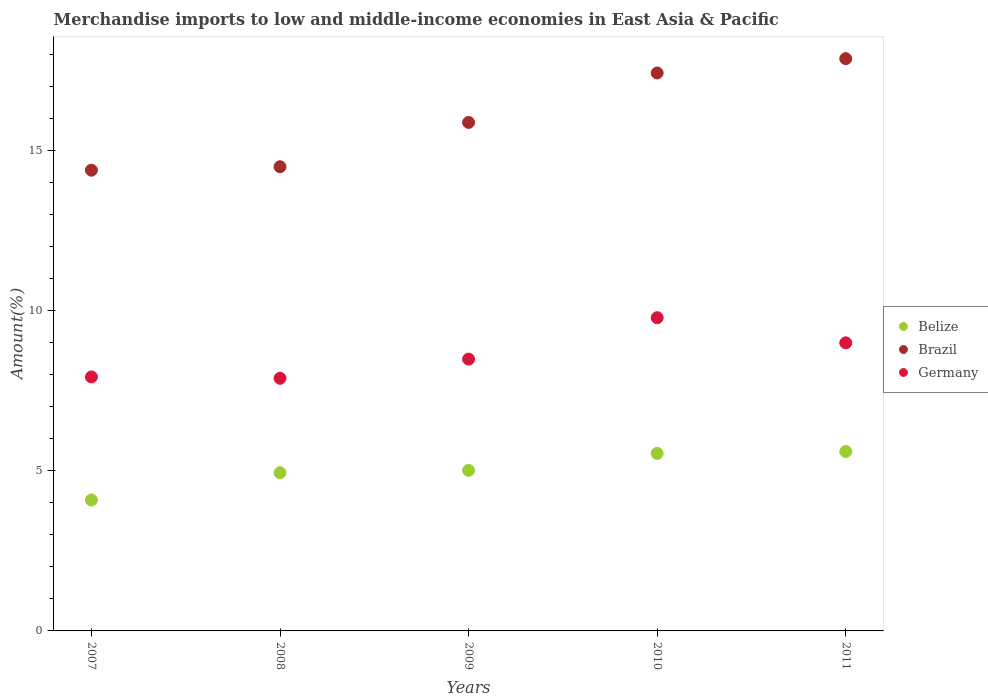What is the percentage of amount earned from merchandise imports in Belize in 2010?
Give a very brief answer. 5.54. Across all years, what is the maximum percentage of amount earned from merchandise imports in Germany?
Your response must be concise. 9.78. Across all years, what is the minimum percentage of amount earned from merchandise imports in Belize?
Offer a very short reply. 4.09. What is the total percentage of amount earned from merchandise imports in Germany in the graph?
Ensure brevity in your answer.  43.07. What is the difference between the percentage of amount earned from merchandise imports in Germany in 2007 and that in 2008?
Your answer should be very brief. 0.04. What is the difference between the percentage of amount earned from merchandise imports in Belize in 2008 and the percentage of amount earned from merchandise imports in Brazil in 2007?
Give a very brief answer. -9.44. What is the average percentage of amount earned from merchandise imports in Belize per year?
Your answer should be very brief. 5.04. In the year 2007, what is the difference between the percentage of amount earned from merchandise imports in Brazil and percentage of amount earned from merchandise imports in Germany?
Provide a succinct answer. 6.45. What is the ratio of the percentage of amount earned from merchandise imports in Belize in 2007 to that in 2009?
Offer a very short reply. 0.82. What is the difference between the highest and the second highest percentage of amount earned from merchandise imports in Brazil?
Make the answer very short. 0.45. What is the difference between the highest and the lowest percentage of amount earned from merchandise imports in Belize?
Give a very brief answer. 1.51. Is the sum of the percentage of amount earned from merchandise imports in Germany in 2007 and 2010 greater than the maximum percentage of amount earned from merchandise imports in Belize across all years?
Give a very brief answer. Yes. Is it the case that in every year, the sum of the percentage of amount earned from merchandise imports in Brazil and percentage of amount earned from merchandise imports in Belize  is greater than the percentage of amount earned from merchandise imports in Germany?
Provide a succinct answer. Yes. Is the percentage of amount earned from merchandise imports in Belize strictly greater than the percentage of amount earned from merchandise imports in Germany over the years?
Provide a short and direct response. No. How many years are there in the graph?
Keep it short and to the point. 5. Does the graph contain any zero values?
Provide a short and direct response. No. Does the graph contain grids?
Give a very brief answer. No. Where does the legend appear in the graph?
Ensure brevity in your answer.  Center right. How many legend labels are there?
Provide a short and direct response. 3. What is the title of the graph?
Provide a succinct answer. Merchandise imports to low and middle-income economies in East Asia & Pacific. What is the label or title of the Y-axis?
Give a very brief answer. Amount(%). What is the Amount(%) of Belize in 2007?
Your answer should be compact. 4.09. What is the Amount(%) in Brazil in 2007?
Offer a very short reply. 14.38. What is the Amount(%) in Germany in 2007?
Offer a very short reply. 7.93. What is the Amount(%) of Belize in 2008?
Give a very brief answer. 4.94. What is the Amount(%) in Brazil in 2008?
Keep it short and to the point. 14.49. What is the Amount(%) in Germany in 2008?
Give a very brief answer. 7.89. What is the Amount(%) in Belize in 2009?
Provide a succinct answer. 5.01. What is the Amount(%) of Brazil in 2009?
Offer a terse response. 15.87. What is the Amount(%) in Germany in 2009?
Your answer should be compact. 8.49. What is the Amount(%) of Belize in 2010?
Your response must be concise. 5.54. What is the Amount(%) of Brazil in 2010?
Your answer should be very brief. 17.42. What is the Amount(%) in Germany in 2010?
Keep it short and to the point. 9.78. What is the Amount(%) of Belize in 2011?
Give a very brief answer. 5.6. What is the Amount(%) of Brazil in 2011?
Your response must be concise. 17.87. What is the Amount(%) in Germany in 2011?
Keep it short and to the point. 8.99. Across all years, what is the maximum Amount(%) of Belize?
Your answer should be compact. 5.6. Across all years, what is the maximum Amount(%) in Brazil?
Keep it short and to the point. 17.87. Across all years, what is the maximum Amount(%) in Germany?
Offer a terse response. 9.78. Across all years, what is the minimum Amount(%) in Belize?
Your answer should be very brief. 4.09. Across all years, what is the minimum Amount(%) of Brazil?
Provide a short and direct response. 14.38. Across all years, what is the minimum Amount(%) in Germany?
Provide a succinct answer. 7.89. What is the total Amount(%) of Belize in the graph?
Offer a very short reply. 25.18. What is the total Amount(%) in Brazil in the graph?
Your answer should be compact. 80.03. What is the total Amount(%) in Germany in the graph?
Make the answer very short. 43.07. What is the difference between the Amount(%) of Belize in 2007 and that in 2008?
Provide a succinct answer. -0.85. What is the difference between the Amount(%) in Brazil in 2007 and that in 2008?
Provide a short and direct response. -0.11. What is the difference between the Amount(%) of Germany in 2007 and that in 2008?
Keep it short and to the point. 0.04. What is the difference between the Amount(%) in Belize in 2007 and that in 2009?
Provide a short and direct response. -0.93. What is the difference between the Amount(%) in Brazil in 2007 and that in 2009?
Your answer should be compact. -1.49. What is the difference between the Amount(%) of Germany in 2007 and that in 2009?
Ensure brevity in your answer.  -0.56. What is the difference between the Amount(%) of Belize in 2007 and that in 2010?
Ensure brevity in your answer.  -1.46. What is the difference between the Amount(%) of Brazil in 2007 and that in 2010?
Provide a succinct answer. -3.03. What is the difference between the Amount(%) in Germany in 2007 and that in 2010?
Ensure brevity in your answer.  -1.85. What is the difference between the Amount(%) of Belize in 2007 and that in 2011?
Your response must be concise. -1.51. What is the difference between the Amount(%) in Brazil in 2007 and that in 2011?
Your answer should be compact. -3.48. What is the difference between the Amount(%) of Germany in 2007 and that in 2011?
Keep it short and to the point. -1.06. What is the difference between the Amount(%) of Belize in 2008 and that in 2009?
Provide a succinct answer. -0.07. What is the difference between the Amount(%) in Brazil in 2008 and that in 2009?
Provide a short and direct response. -1.38. What is the difference between the Amount(%) in Germany in 2008 and that in 2009?
Give a very brief answer. -0.6. What is the difference between the Amount(%) in Belize in 2008 and that in 2010?
Your response must be concise. -0.6. What is the difference between the Amount(%) of Brazil in 2008 and that in 2010?
Keep it short and to the point. -2.93. What is the difference between the Amount(%) in Germany in 2008 and that in 2010?
Your answer should be compact. -1.89. What is the difference between the Amount(%) of Belize in 2008 and that in 2011?
Provide a succinct answer. -0.66. What is the difference between the Amount(%) of Brazil in 2008 and that in 2011?
Provide a short and direct response. -3.37. What is the difference between the Amount(%) of Germany in 2008 and that in 2011?
Provide a short and direct response. -1.11. What is the difference between the Amount(%) of Belize in 2009 and that in 2010?
Give a very brief answer. -0.53. What is the difference between the Amount(%) in Brazil in 2009 and that in 2010?
Your answer should be very brief. -1.54. What is the difference between the Amount(%) of Germany in 2009 and that in 2010?
Your answer should be compact. -1.29. What is the difference between the Amount(%) of Belize in 2009 and that in 2011?
Keep it short and to the point. -0.59. What is the difference between the Amount(%) of Brazil in 2009 and that in 2011?
Keep it short and to the point. -1.99. What is the difference between the Amount(%) in Germany in 2009 and that in 2011?
Provide a short and direct response. -0.51. What is the difference between the Amount(%) of Belize in 2010 and that in 2011?
Offer a very short reply. -0.06. What is the difference between the Amount(%) in Brazil in 2010 and that in 2011?
Make the answer very short. -0.45. What is the difference between the Amount(%) of Germany in 2010 and that in 2011?
Provide a succinct answer. 0.78. What is the difference between the Amount(%) in Belize in 2007 and the Amount(%) in Brazil in 2008?
Offer a very short reply. -10.4. What is the difference between the Amount(%) of Belize in 2007 and the Amount(%) of Germany in 2008?
Provide a short and direct response. -3.8. What is the difference between the Amount(%) in Brazil in 2007 and the Amount(%) in Germany in 2008?
Your answer should be compact. 6.5. What is the difference between the Amount(%) in Belize in 2007 and the Amount(%) in Brazil in 2009?
Give a very brief answer. -11.79. What is the difference between the Amount(%) in Belize in 2007 and the Amount(%) in Germany in 2009?
Provide a succinct answer. -4.4. What is the difference between the Amount(%) in Brazil in 2007 and the Amount(%) in Germany in 2009?
Your answer should be very brief. 5.9. What is the difference between the Amount(%) in Belize in 2007 and the Amount(%) in Brazil in 2010?
Your response must be concise. -13.33. What is the difference between the Amount(%) of Belize in 2007 and the Amount(%) of Germany in 2010?
Provide a short and direct response. -5.69. What is the difference between the Amount(%) of Brazil in 2007 and the Amount(%) of Germany in 2010?
Make the answer very short. 4.61. What is the difference between the Amount(%) of Belize in 2007 and the Amount(%) of Brazil in 2011?
Your response must be concise. -13.78. What is the difference between the Amount(%) of Belize in 2007 and the Amount(%) of Germany in 2011?
Your response must be concise. -4.91. What is the difference between the Amount(%) of Brazil in 2007 and the Amount(%) of Germany in 2011?
Make the answer very short. 5.39. What is the difference between the Amount(%) of Belize in 2008 and the Amount(%) of Brazil in 2009?
Make the answer very short. -10.93. What is the difference between the Amount(%) of Belize in 2008 and the Amount(%) of Germany in 2009?
Ensure brevity in your answer.  -3.55. What is the difference between the Amount(%) of Brazil in 2008 and the Amount(%) of Germany in 2009?
Your response must be concise. 6.01. What is the difference between the Amount(%) of Belize in 2008 and the Amount(%) of Brazil in 2010?
Make the answer very short. -12.48. What is the difference between the Amount(%) of Belize in 2008 and the Amount(%) of Germany in 2010?
Keep it short and to the point. -4.84. What is the difference between the Amount(%) of Brazil in 2008 and the Amount(%) of Germany in 2010?
Ensure brevity in your answer.  4.71. What is the difference between the Amount(%) in Belize in 2008 and the Amount(%) in Brazil in 2011?
Give a very brief answer. -12.93. What is the difference between the Amount(%) in Belize in 2008 and the Amount(%) in Germany in 2011?
Provide a short and direct response. -4.05. What is the difference between the Amount(%) in Brazil in 2008 and the Amount(%) in Germany in 2011?
Your response must be concise. 5.5. What is the difference between the Amount(%) of Belize in 2009 and the Amount(%) of Brazil in 2010?
Your response must be concise. -12.41. What is the difference between the Amount(%) in Belize in 2009 and the Amount(%) in Germany in 2010?
Offer a terse response. -4.77. What is the difference between the Amount(%) of Brazil in 2009 and the Amount(%) of Germany in 2010?
Your answer should be very brief. 6.1. What is the difference between the Amount(%) of Belize in 2009 and the Amount(%) of Brazil in 2011?
Give a very brief answer. -12.85. What is the difference between the Amount(%) in Belize in 2009 and the Amount(%) in Germany in 2011?
Keep it short and to the point. -3.98. What is the difference between the Amount(%) in Brazil in 2009 and the Amount(%) in Germany in 2011?
Your response must be concise. 6.88. What is the difference between the Amount(%) in Belize in 2010 and the Amount(%) in Brazil in 2011?
Ensure brevity in your answer.  -12.32. What is the difference between the Amount(%) of Belize in 2010 and the Amount(%) of Germany in 2011?
Provide a succinct answer. -3.45. What is the difference between the Amount(%) of Brazil in 2010 and the Amount(%) of Germany in 2011?
Offer a very short reply. 8.42. What is the average Amount(%) of Belize per year?
Provide a succinct answer. 5.04. What is the average Amount(%) of Brazil per year?
Your answer should be very brief. 16.01. What is the average Amount(%) of Germany per year?
Your answer should be compact. 8.61. In the year 2007, what is the difference between the Amount(%) of Belize and Amount(%) of Brazil?
Your response must be concise. -10.3. In the year 2007, what is the difference between the Amount(%) of Belize and Amount(%) of Germany?
Provide a succinct answer. -3.84. In the year 2007, what is the difference between the Amount(%) of Brazil and Amount(%) of Germany?
Keep it short and to the point. 6.45. In the year 2008, what is the difference between the Amount(%) in Belize and Amount(%) in Brazil?
Make the answer very short. -9.55. In the year 2008, what is the difference between the Amount(%) in Belize and Amount(%) in Germany?
Provide a succinct answer. -2.95. In the year 2008, what is the difference between the Amount(%) in Brazil and Amount(%) in Germany?
Make the answer very short. 6.6. In the year 2009, what is the difference between the Amount(%) in Belize and Amount(%) in Brazil?
Ensure brevity in your answer.  -10.86. In the year 2009, what is the difference between the Amount(%) in Belize and Amount(%) in Germany?
Provide a short and direct response. -3.47. In the year 2009, what is the difference between the Amount(%) of Brazil and Amount(%) of Germany?
Provide a succinct answer. 7.39. In the year 2010, what is the difference between the Amount(%) of Belize and Amount(%) of Brazil?
Provide a short and direct response. -11.88. In the year 2010, what is the difference between the Amount(%) of Belize and Amount(%) of Germany?
Your answer should be compact. -4.24. In the year 2010, what is the difference between the Amount(%) in Brazil and Amount(%) in Germany?
Keep it short and to the point. 7.64. In the year 2011, what is the difference between the Amount(%) of Belize and Amount(%) of Brazil?
Your response must be concise. -12.27. In the year 2011, what is the difference between the Amount(%) of Belize and Amount(%) of Germany?
Make the answer very short. -3.39. In the year 2011, what is the difference between the Amount(%) of Brazil and Amount(%) of Germany?
Your answer should be very brief. 8.87. What is the ratio of the Amount(%) in Belize in 2007 to that in 2008?
Ensure brevity in your answer.  0.83. What is the ratio of the Amount(%) in Brazil in 2007 to that in 2008?
Keep it short and to the point. 0.99. What is the ratio of the Amount(%) of Germany in 2007 to that in 2008?
Provide a short and direct response. 1.01. What is the ratio of the Amount(%) of Belize in 2007 to that in 2009?
Your response must be concise. 0.82. What is the ratio of the Amount(%) in Brazil in 2007 to that in 2009?
Give a very brief answer. 0.91. What is the ratio of the Amount(%) in Germany in 2007 to that in 2009?
Give a very brief answer. 0.93. What is the ratio of the Amount(%) of Belize in 2007 to that in 2010?
Provide a succinct answer. 0.74. What is the ratio of the Amount(%) in Brazil in 2007 to that in 2010?
Offer a terse response. 0.83. What is the ratio of the Amount(%) in Germany in 2007 to that in 2010?
Keep it short and to the point. 0.81. What is the ratio of the Amount(%) in Belize in 2007 to that in 2011?
Give a very brief answer. 0.73. What is the ratio of the Amount(%) of Brazil in 2007 to that in 2011?
Ensure brevity in your answer.  0.81. What is the ratio of the Amount(%) in Germany in 2007 to that in 2011?
Provide a succinct answer. 0.88. What is the ratio of the Amount(%) in Belize in 2008 to that in 2009?
Keep it short and to the point. 0.99. What is the ratio of the Amount(%) of Brazil in 2008 to that in 2009?
Provide a succinct answer. 0.91. What is the ratio of the Amount(%) in Germany in 2008 to that in 2009?
Make the answer very short. 0.93. What is the ratio of the Amount(%) in Belize in 2008 to that in 2010?
Provide a succinct answer. 0.89. What is the ratio of the Amount(%) in Brazil in 2008 to that in 2010?
Your response must be concise. 0.83. What is the ratio of the Amount(%) of Germany in 2008 to that in 2010?
Make the answer very short. 0.81. What is the ratio of the Amount(%) of Belize in 2008 to that in 2011?
Provide a short and direct response. 0.88. What is the ratio of the Amount(%) of Brazil in 2008 to that in 2011?
Give a very brief answer. 0.81. What is the ratio of the Amount(%) in Germany in 2008 to that in 2011?
Offer a terse response. 0.88. What is the ratio of the Amount(%) of Belize in 2009 to that in 2010?
Provide a short and direct response. 0.9. What is the ratio of the Amount(%) of Brazil in 2009 to that in 2010?
Provide a succinct answer. 0.91. What is the ratio of the Amount(%) in Germany in 2009 to that in 2010?
Give a very brief answer. 0.87. What is the ratio of the Amount(%) in Belize in 2009 to that in 2011?
Ensure brevity in your answer.  0.89. What is the ratio of the Amount(%) in Brazil in 2009 to that in 2011?
Your response must be concise. 0.89. What is the ratio of the Amount(%) of Germany in 2009 to that in 2011?
Your answer should be very brief. 0.94. What is the ratio of the Amount(%) in Brazil in 2010 to that in 2011?
Give a very brief answer. 0.97. What is the ratio of the Amount(%) in Germany in 2010 to that in 2011?
Offer a very short reply. 1.09. What is the difference between the highest and the second highest Amount(%) in Belize?
Give a very brief answer. 0.06. What is the difference between the highest and the second highest Amount(%) of Brazil?
Your answer should be compact. 0.45. What is the difference between the highest and the second highest Amount(%) of Germany?
Your answer should be very brief. 0.78. What is the difference between the highest and the lowest Amount(%) in Belize?
Your response must be concise. 1.51. What is the difference between the highest and the lowest Amount(%) of Brazil?
Your answer should be very brief. 3.48. What is the difference between the highest and the lowest Amount(%) in Germany?
Offer a very short reply. 1.89. 